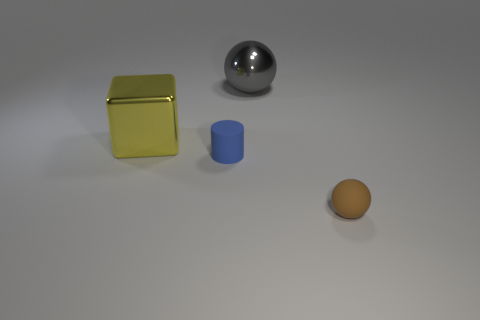Is the yellow thing made of the same material as the gray ball?
Make the answer very short. Yes. Are there the same number of small brown spheres that are behind the large block and gray blocks?
Give a very brief answer. Yes. How many big yellow cubes are the same material as the large sphere?
Make the answer very short. 1. Are there fewer small blue cylinders than big cyan metallic spheres?
Provide a succinct answer. No. There is a rubber object that is to the right of the big gray thing; is its color the same as the metal block?
Give a very brief answer. No. There is a object behind the shiny object that is left of the big gray shiny object; how many large gray metallic objects are to the left of it?
Give a very brief answer. 0. There is a big gray shiny object; what number of brown matte objects are behind it?
Your answer should be compact. 0. There is a big metal thing that is the same shape as the small brown object; what is its color?
Your answer should be very brief. Gray. There is a thing that is behind the matte cylinder and to the right of the big yellow thing; what material is it?
Provide a short and direct response. Metal. There is a ball on the left side of the brown object; is its size the same as the metal cube?
Ensure brevity in your answer.  Yes. 